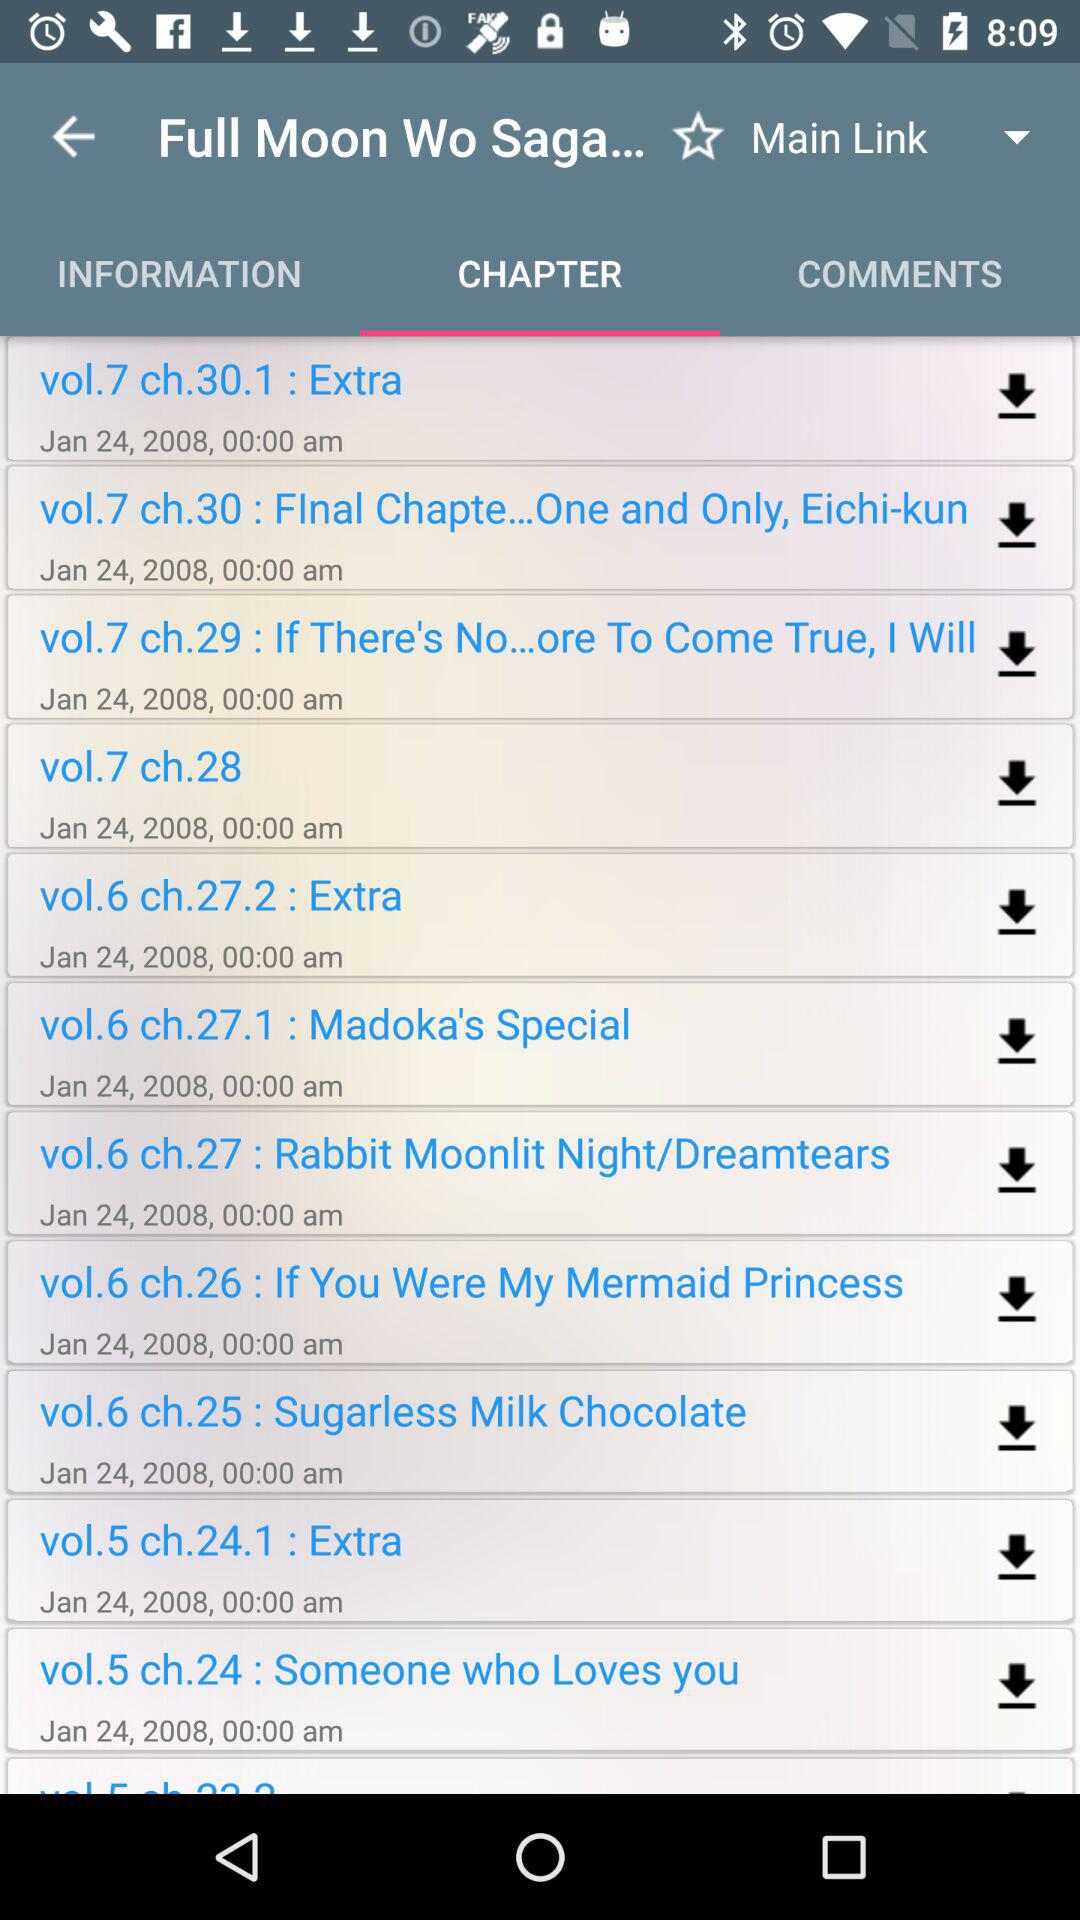On what date is the chapter of Vol 7.ch.28 uploaded? The date is January 24th, 2008. 